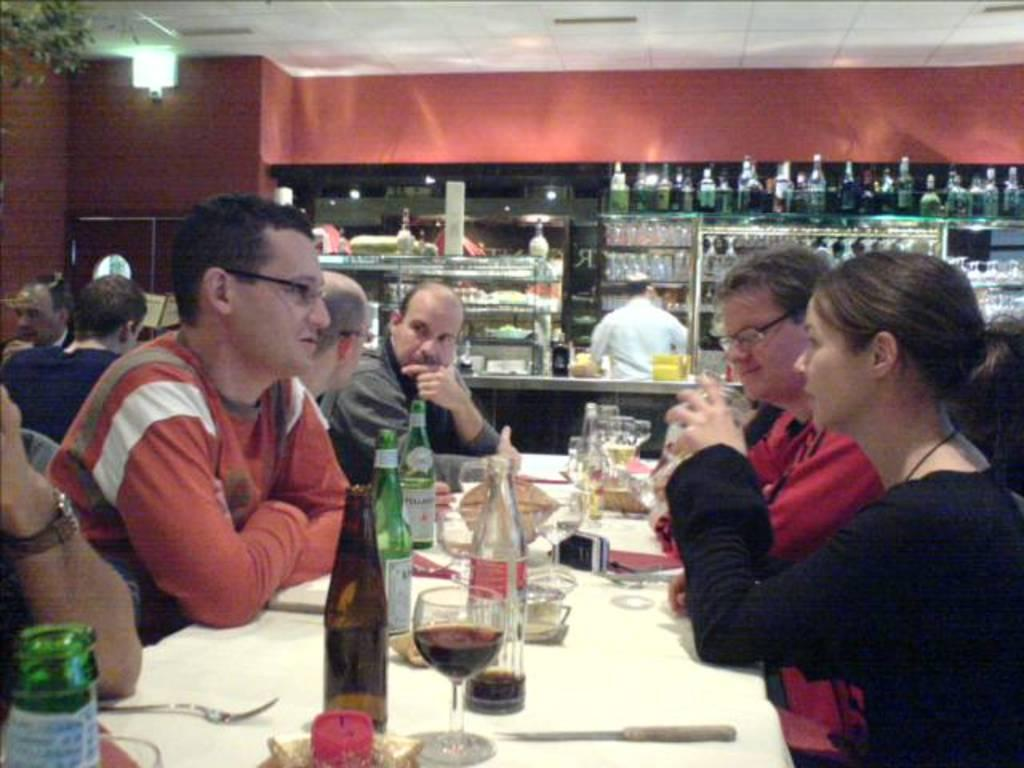What are the people in the image doing? There is a group of people sitting together in the image. Where are they sitting? They are sitting at a dining table. What can be seen on the table? There are beer glasses and wine glasses on the table. Can you describe the lighting in the image? There is a light on the left side of the image. What reason does the deer have for being in the image? There is no deer present in the image, so it cannot be determined if it has a reason for being there. 